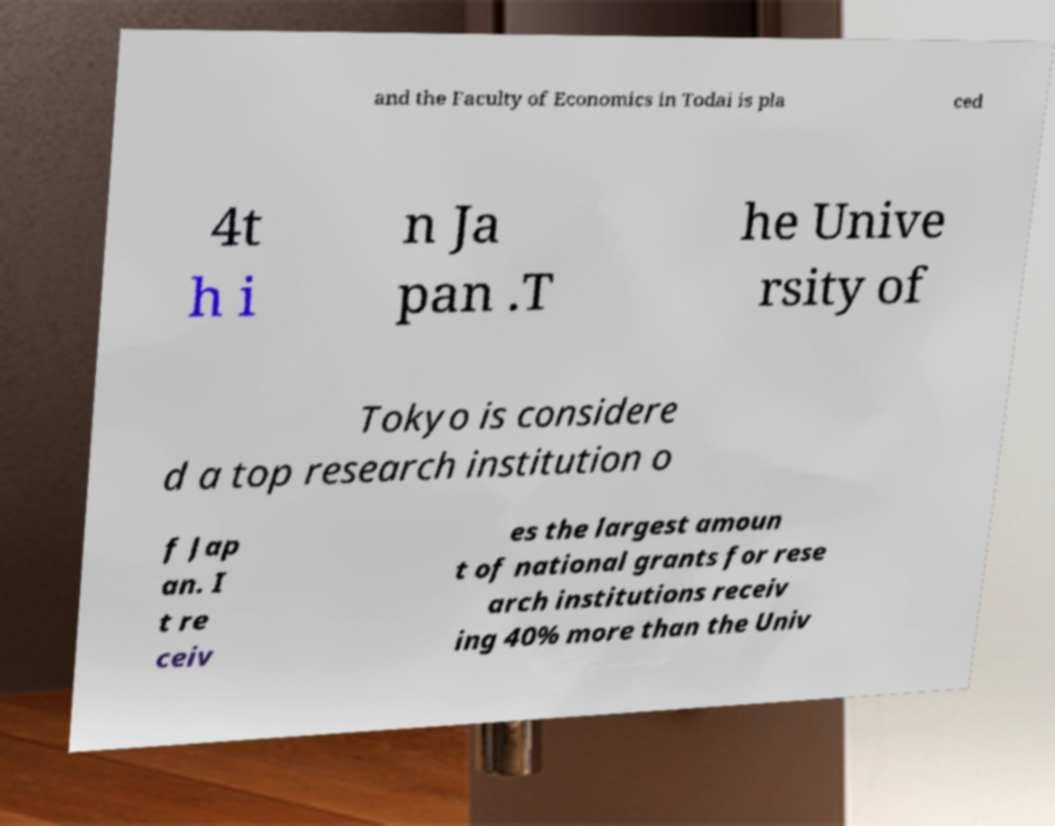For documentation purposes, I need the text within this image transcribed. Could you provide that? and the Faculty of Economics in Todai is pla ced 4t h i n Ja pan .T he Unive rsity of Tokyo is considere d a top research institution o f Jap an. I t re ceiv es the largest amoun t of national grants for rese arch institutions receiv ing 40% more than the Univ 